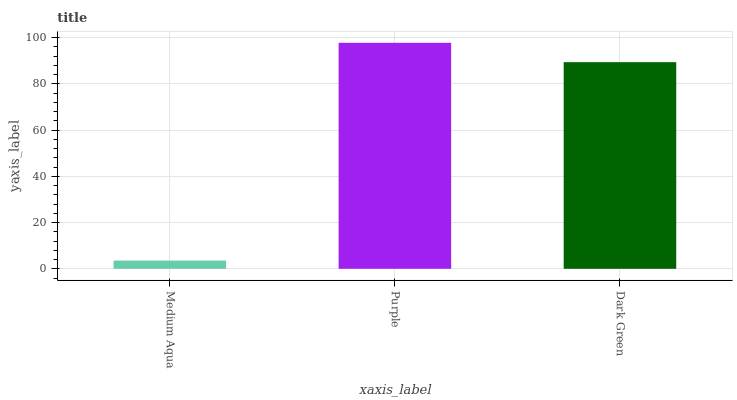Is Medium Aqua the minimum?
Answer yes or no. Yes. Is Purple the maximum?
Answer yes or no. Yes. Is Dark Green the minimum?
Answer yes or no. No. Is Dark Green the maximum?
Answer yes or no. No. Is Purple greater than Dark Green?
Answer yes or no. Yes. Is Dark Green less than Purple?
Answer yes or no. Yes. Is Dark Green greater than Purple?
Answer yes or no. No. Is Purple less than Dark Green?
Answer yes or no. No. Is Dark Green the high median?
Answer yes or no. Yes. Is Dark Green the low median?
Answer yes or no. Yes. Is Medium Aqua the high median?
Answer yes or no. No. Is Purple the low median?
Answer yes or no. No. 